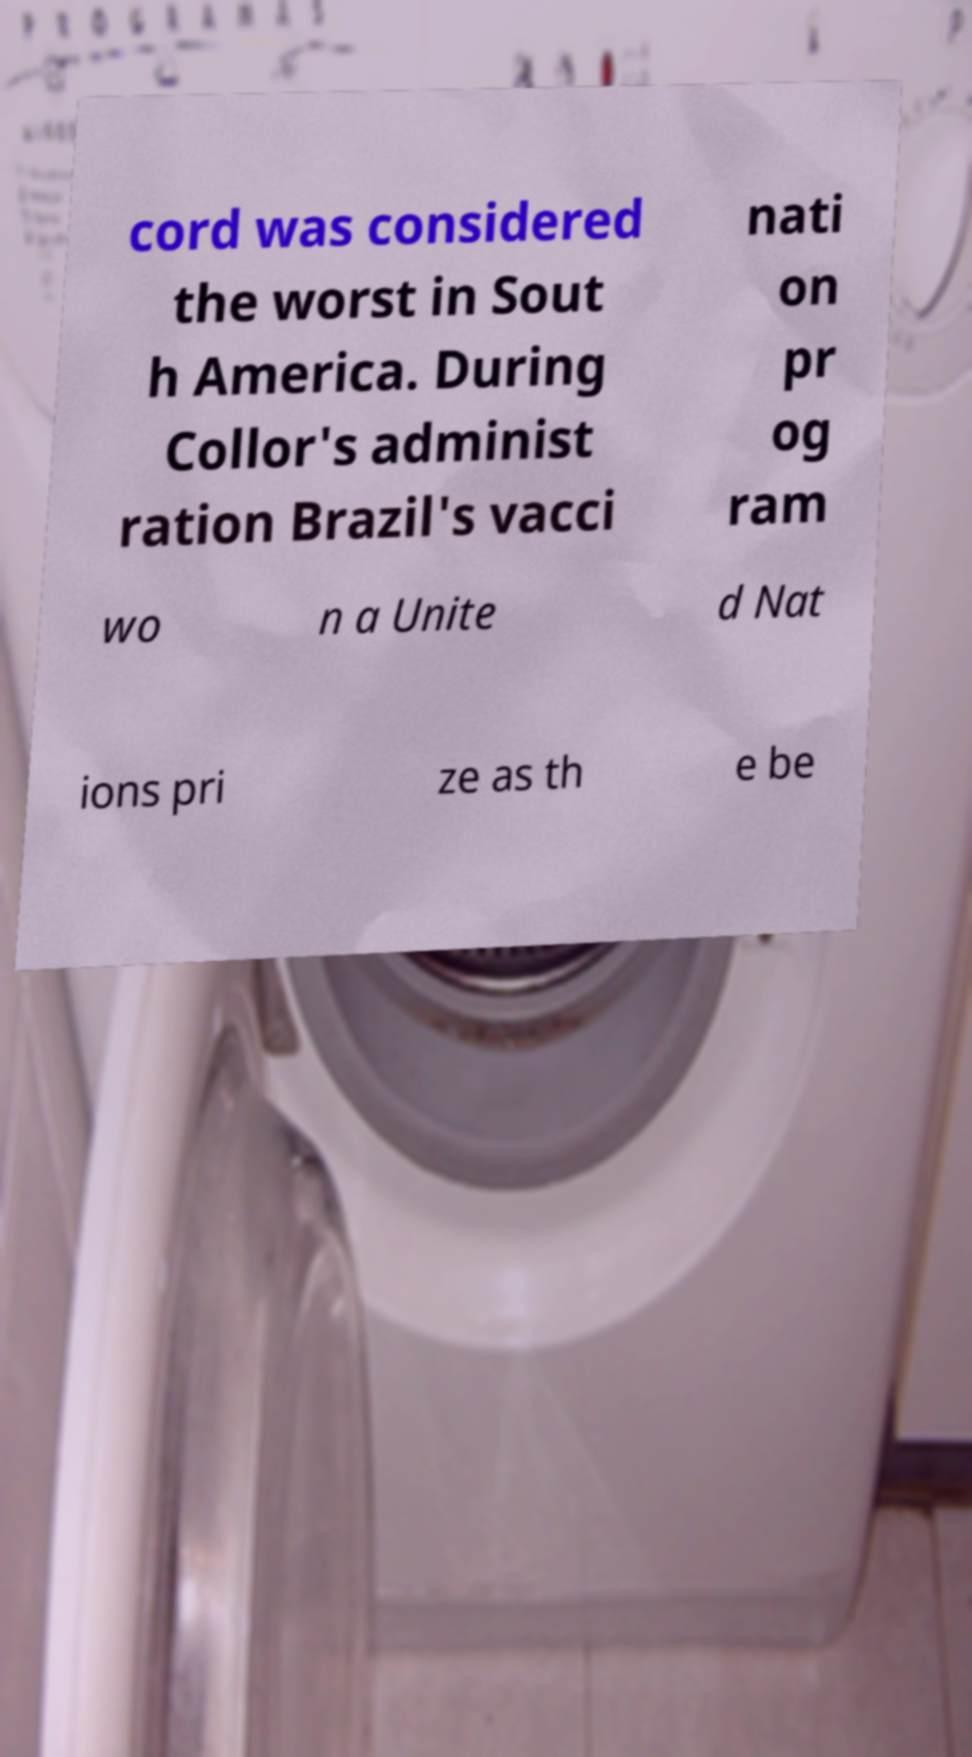Could you extract and type out the text from this image? cord was considered the worst in Sout h America. During Collor's administ ration Brazil's vacci nati on pr og ram wo n a Unite d Nat ions pri ze as th e be 